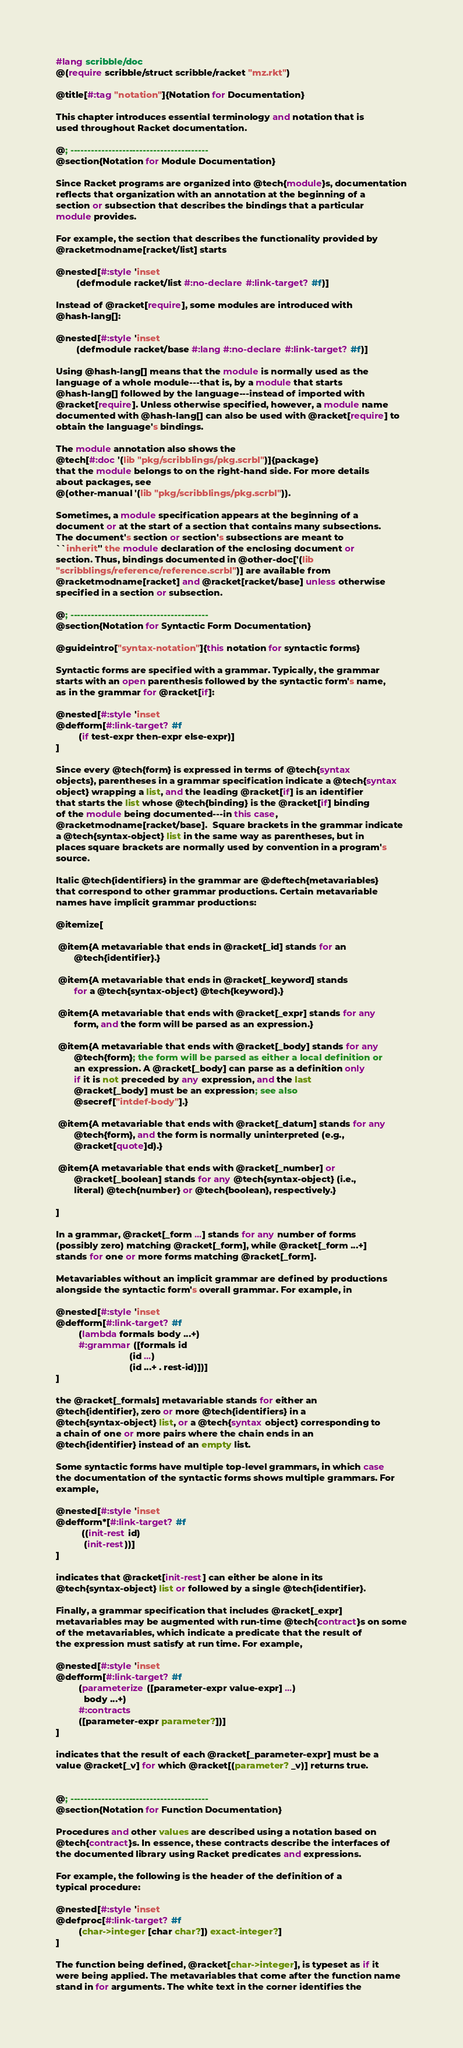Convert code to text. <code><loc_0><loc_0><loc_500><loc_500><_Racket_>#lang scribble/doc
@(require scribble/struct scribble/racket "mz.rkt")

@title[#:tag "notation"]{Notation for Documentation}

This chapter introduces essential terminology and notation that is
used throughout Racket documentation.

@; ----------------------------------------
@section{Notation for Module Documentation}

Since Racket programs are organized into @tech{module}s, documentation
reflects that organization with an annotation at the beginning of a
section or subsection that describes the bindings that a particular
module provides.

For example, the section that describes the functionality provided by
@racketmodname[racket/list] starts

@nested[#:style 'inset
        (defmodule racket/list #:no-declare #:link-target? #f)]

Instead of @racket[require], some modules are introduced with
@hash-lang[]:

@nested[#:style 'inset
        (defmodule racket/base #:lang #:no-declare #:link-target? #f)]

Using @hash-lang[] means that the module is normally used as the
language of a whole module---that is, by a module that starts
@hash-lang[] followed by the language---instead of imported with
@racket[require]. Unless otherwise specified, however, a module name
documented with @hash-lang[] can also be used with @racket[require] to
obtain the language's bindings.

The module annotation also shows the
@tech[#:doc '(lib "pkg/scribblings/pkg.scrbl")]{package}
that the module belongs to on the right-hand side. For more details
about packages, see
@(other-manual '(lib "pkg/scribblings/pkg.scrbl")).

Sometimes, a module specification appears at the beginning of a
document or at the start of a section that contains many subsections.
The document's section or section's subsections are meant to
``inherit'' the module declaration of the enclosing document or
section. Thus, bindings documented in @other-doc['(lib
"scribblings/reference/reference.scrbl")] are available from
@racketmodname[racket] and @racket[racket/base] unless otherwise
specified in a section or subsection.

@; ----------------------------------------
@section{Notation for Syntactic Form Documentation}

@guideintro["syntax-notation"]{this notation for syntactic forms}

Syntactic forms are specified with a grammar. Typically, the grammar
starts with an open parenthesis followed by the syntactic form's name,
as in the grammar for @racket[if]:

@nested[#:style 'inset
@defform[#:link-target? #f
         (if test-expr then-expr else-expr)]
]

Since every @tech{form} is expressed in terms of @tech{syntax
objects}, parentheses in a grammar specification indicate a @tech{syntax
object} wrapping a list, and the leading @racket[if] is an identifier
that starts the list whose @tech{binding} is the @racket[if] binding
of the module being documented---in this case,
@racketmodname[racket/base].  Square brackets in the grammar indicate
a @tech{syntax-object} list in the same way as parentheses, but in
places square brackets are normally used by convention in a program's
source.

Italic @tech{identifiers} in the grammar are @deftech{metavariables}
that correspond to other grammar productions. Certain metavariable
names have implicit grammar productions:

@itemize[

 @item{A metavariable that ends in @racket[_id] stands for an
       @tech{identifier}.}

 @item{A metavariable that ends in @racket[_keyword] stands
       for a @tech{syntax-object} @tech{keyword}.}

 @item{A metavariable that ends with @racket[_expr] stands for any
       form, and the form will be parsed as an expression.}

 @item{A metavariable that ends with @racket[_body] stands for any
       @tech{form}; the form will be parsed as either a local definition or
       an expression. A @racket[_body] can parse as a definition only
       if it is not preceded by any expression, and the last
       @racket[_body] must be an expression; see also
       @secref["intdef-body"].}

 @item{A metavariable that ends with @racket[_datum] stands for any
       @tech{form}, and the form is normally uninterpreted (e.g.,
       @racket[quote]d).}

 @item{A metavariable that ends with @racket[_number] or
       @racket[_boolean] stands for any @tech{syntax-object} (i.e.,
       literal) @tech{number} or @tech{boolean}, respectively.}

]

In a grammar, @racket[_form ...] stands for any number of forms
(possibly zero) matching @racket[_form], while @racket[_form ...+]
stands for one or more forms matching @racket[_form].

Metavariables without an implicit grammar are defined by productions
alongside the syntactic form's overall grammar. For example, in

@nested[#:style 'inset
@defform[#:link-target? #f
         (lambda formals body ...+)
         #:grammar ([formals id
                             (id ...)
                             (id ...+ . rest-id)])]
]

the @racket[_formals] metavariable stands for either an
@tech{identifier}, zero or more @tech{identifiers} in a
@tech{syntax-object} list, or a @tech{syntax object} corresponding to
a chain of one or more pairs where the chain ends in an
@tech{identifier} instead of an empty list.

Some syntactic forms have multiple top-level grammars, in which case
the documentation of the syntactic forms shows multiple grammars. For
example,

@nested[#:style 'inset
@defform*[#:link-target? #f
          ((init-rest id)
           (init-rest))]
]

indicates that @racket[init-rest] can either be alone in its
@tech{syntax-object} list or followed by a single @tech{identifier}.

Finally, a grammar specification that includes @racket[_expr]
metavariables may be augmented with run-time @tech{contract}s on some
of the metavariables, which indicate a predicate that the result of
the expression must satisfy at run time. For example,

@nested[#:style 'inset
@defform[#:link-target? #f
         (parameterize ([parameter-expr value-expr] ...)
           body ...+)
         #:contracts
         ([parameter-expr parameter?])]
]

indicates that the result of each @racket[_parameter-expr] must be a
value @racket[_v] for which @racket[(parameter? _v)] returns true.


@; ----------------------------------------
@section{Notation for Function Documentation}

Procedures and other values are described using a notation based on
@tech{contract}s. In essence, these contracts describe the interfaces of
the documented library using Racket predicates and expressions.

For example, the following is the header of the definition of a
typical procedure:

@nested[#:style 'inset
@defproc[#:link-target? #f
         (char->integer [char char?]) exact-integer?]
]

The function being defined, @racket[char->integer], is typeset as if it
were being applied. The metavariables that come after the function name
stand in for arguments. The white text in the corner identifies the</code> 